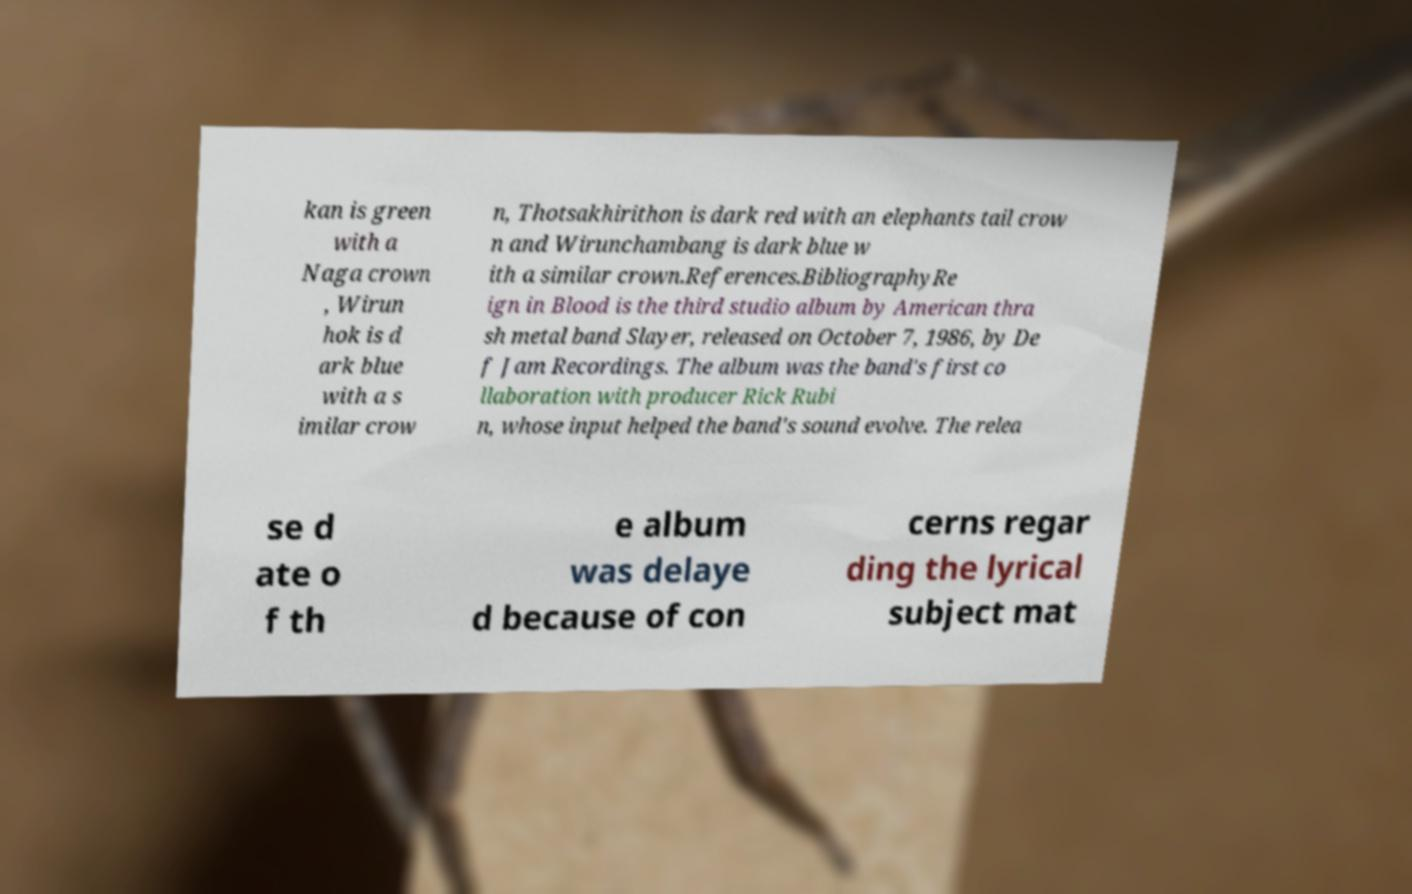What messages or text are displayed in this image? I need them in a readable, typed format. kan is green with a Naga crown , Wirun hok is d ark blue with a s imilar crow n, Thotsakhirithon is dark red with an elephants tail crow n and Wirunchambang is dark blue w ith a similar crown.References.BibliographyRe ign in Blood is the third studio album by American thra sh metal band Slayer, released on October 7, 1986, by De f Jam Recordings. The album was the band's first co llaboration with producer Rick Rubi n, whose input helped the band's sound evolve. The relea se d ate o f th e album was delaye d because of con cerns regar ding the lyrical subject mat 